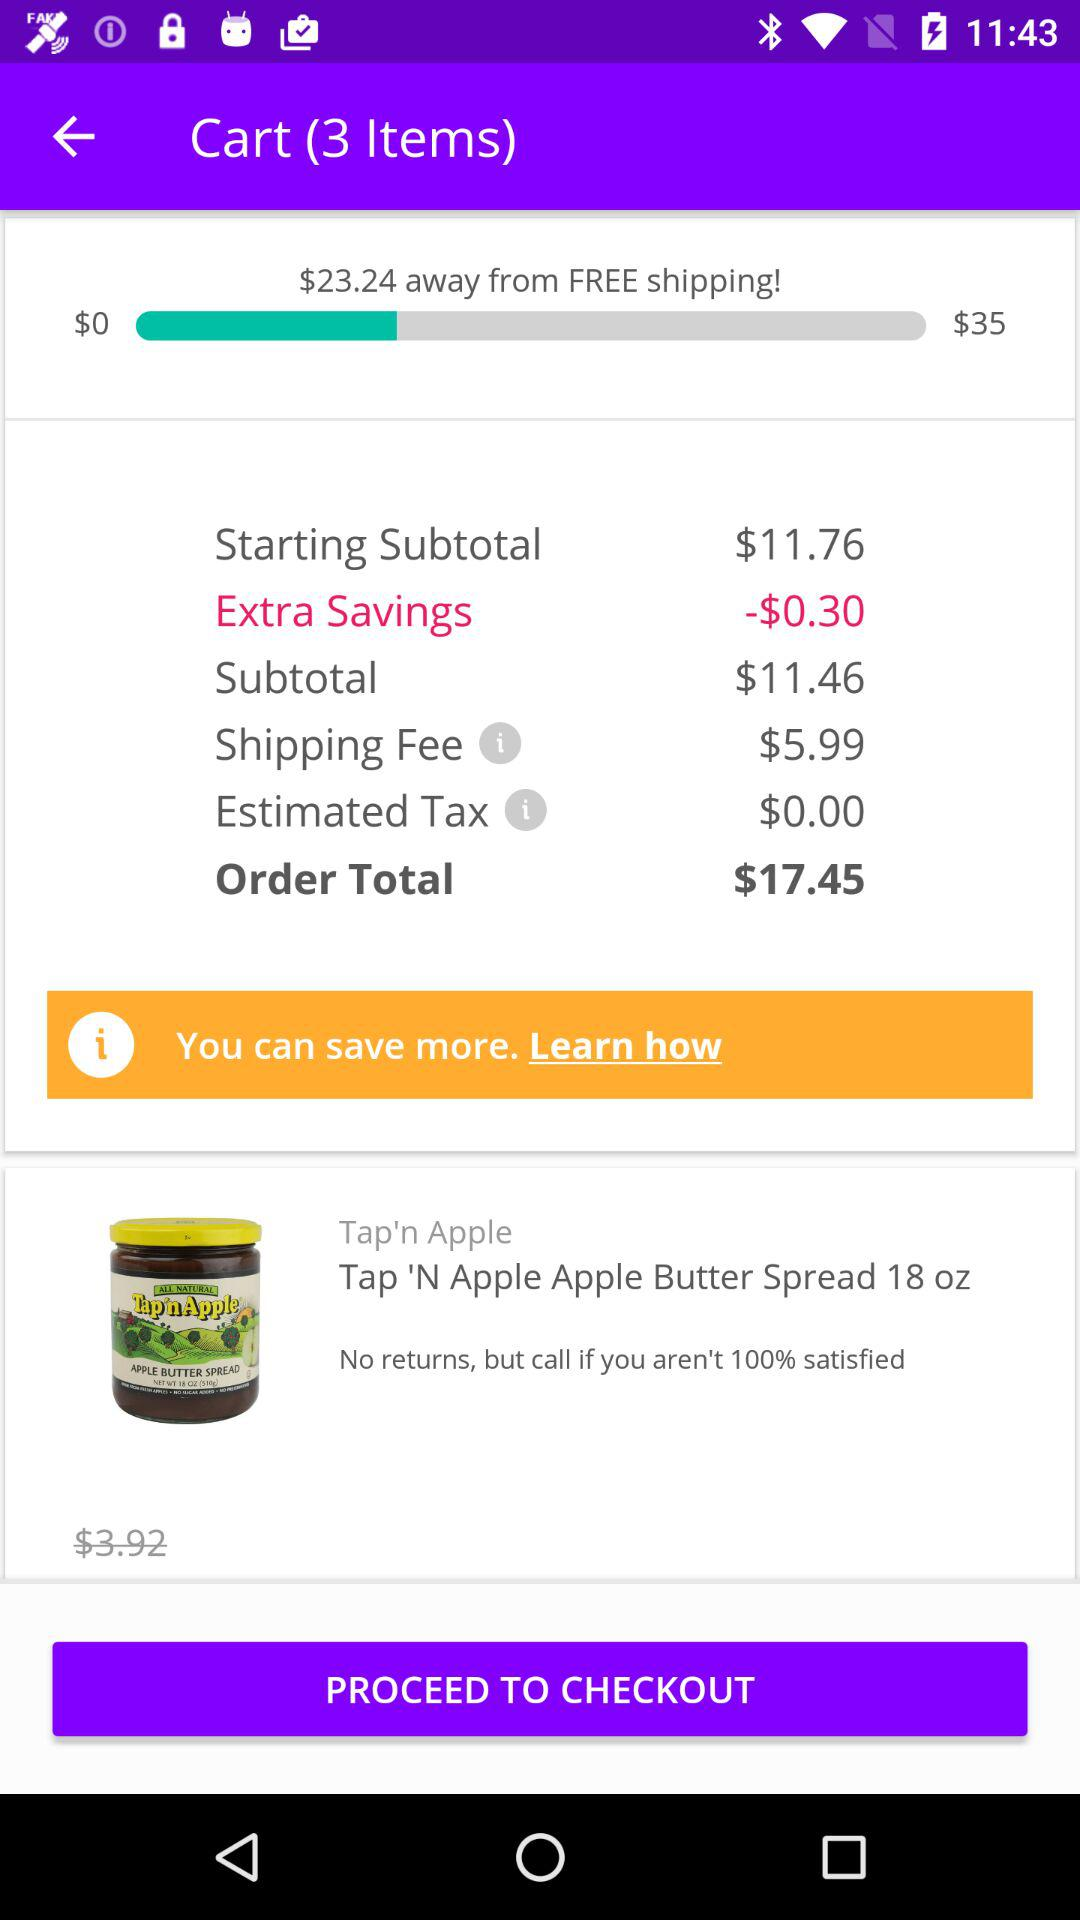How many items are in the cart? There are 3 items in the cart. 